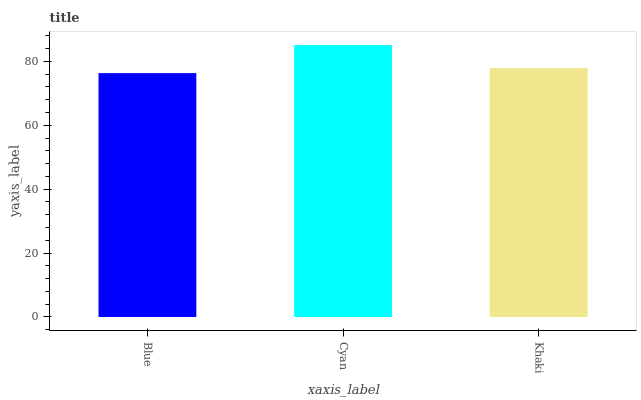Is Blue the minimum?
Answer yes or no. Yes. Is Cyan the maximum?
Answer yes or no. Yes. Is Khaki the minimum?
Answer yes or no. No. Is Khaki the maximum?
Answer yes or no. No. Is Cyan greater than Khaki?
Answer yes or no. Yes. Is Khaki less than Cyan?
Answer yes or no. Yes. Is Khaki greater than Cyan?
Answer yes or no. No. Is Cyan less than Khaki?
Answer yes or no. No. Is Khaki the high median?
Answer yes or no. Yes. Is Khaki the low median?
Answer yes or no. Yes. Is Blue the high median?
Answer yes or no. No. Is Blue the low median?
Answer yes or no. No. 